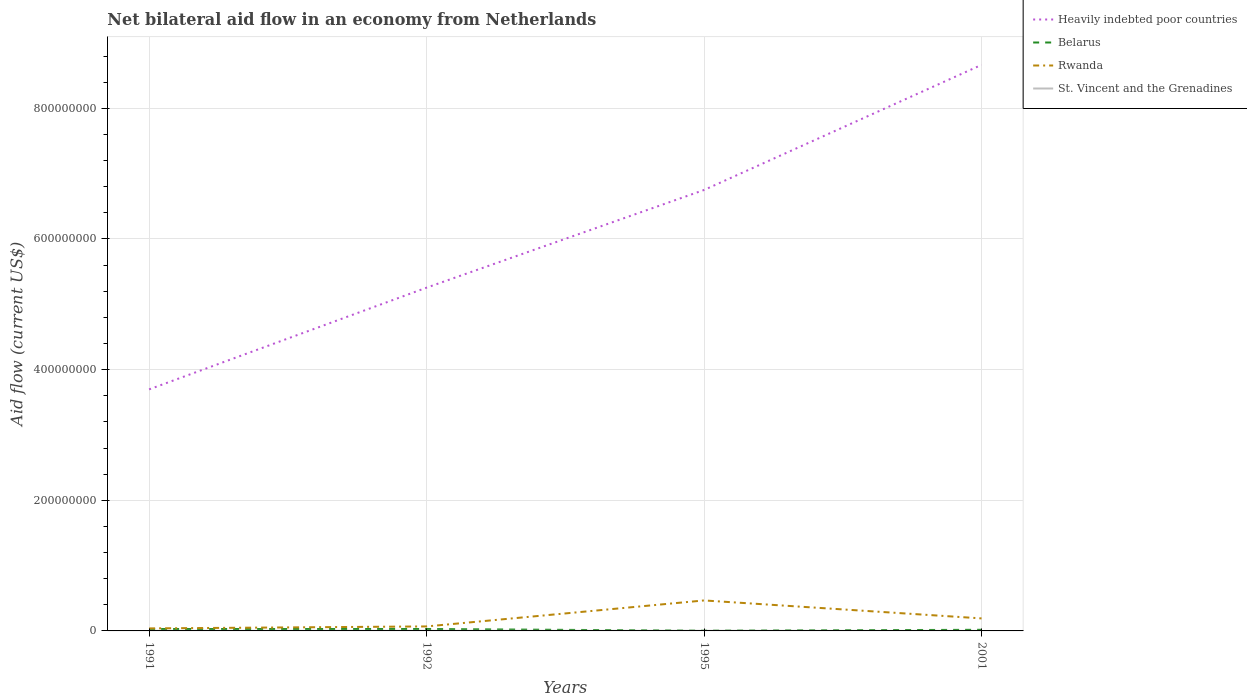How many different coloured lines are there?
Ensure brevity in your answer.  4. Does the line corresponding to Rwanda intersect with the line corresponding to Heavily indebted poor countries?
Give a very brief answer. No. Across all years, what is the maximum net bilateral aid flow in Heavily indebted poor countries?
Keep it short and to the point. 3.70e+08. In which year was the net bilateral aid flow in St. Vincent and the Grenadines maximum?
Give a very brief answer. 2001. What is the total net bilateral aid flow in Rwanda in the graph?
Your response must be concise. -1.23e+07. Is the net bilateral aid flow in Heavily indebted poor countries strictly greater than the net bilateral aid flow in St. Vincent and the Grenadines over the years?
Make the answer very short. No. What is the difference between two consecutive major ticks on the Y-axis?
Your answer should be compact. 2.00e+08. Does the graph contain grids?
Provide a succinct answer. Yes. Where does the legend appear in the graph?
Offer a terse response. Top right. What is the title of the graph?
Provide a short and direct response. Net bilateral aid flow in an economy from Netherlands. What is the label or title of the Y-axis?
Your response must be concise. Aid flow (current US$). What is the Aid flow (current US$) in Heavily indebted poor countries in 1991?
Keep it short and to the point. 3.70e+08. What is the Aid flow (current US$) of Belarus in 1991?
Keep it short and to the point. 2.90e+06. What is the Aid flow (current US$) in Rwanda in 1991?
Ensure brevity in your answer.  3.86e+06. What is the Aid flow (current US$) of St. Vincent and the Grenadines in 1991?
Make the answer very short. 1.10e+05. What is the Aid flow (current US$) of Heavily indebted poor countries in 1992?
Ensure brevity in your answer.  5.25e+08. What is the Aid flow (current US$) in Belarus in 1992?
Your response must be concise. 2.90e+06. What is the Aid flow (current US$) of Rwanda in 1992?
Your answer should be very brief. 6.88e+06. What is the Aid flow (current US$) of Heavily indebted poor countries in 1995?
Keep it short and to the point. 6.75e+08. What is the Aid flow (current US$) of Rwanda in 1995?
Your answer should be compact. 4.67e+07. What is the Aid flow (current US$) in St. Vincent and the Grenadines in 1995?
Provide a succinct answer. 1.60e+05. What is the Aid flow (current US$) in Heavily indebted poor countries in 2001?
Provide a succinct answer. 8.67e+08. What is the Aid flow (current US$) in Belarus in 2001?
Give a very brief answer. 1.72e+06. What is the Aid flow (current US$) of Rwanda in 2001?
Your answer should be compact. 1.92e+07. What is the Aid flow (current US$) in St. Vincent and the Grenadines in 2001?
Offer a very short reply. 5.00e+04. Across all years, what is the maximum Aid flow (current US$) in Heavily indebted poor countries?
Your answer should be very brief. 8.67e+08. Across all years, what is the maximum Aid flow (current US$) in Belarus?
Keep it short and to the point. 2.90e+06. Across all years, what is the maximum Aid flow (current US$) in Rwanda?
Your answer should be compact. 4.67e+07. Across all years, what is the maximum Aid flow (current US$) of St. Vincent and the Grenadines?
Offer a very short reply. 1.60e+05. Across all years, what is the minimum Aid flow (current US$) of Heavily indebted poor countries?
Give a very brief answer. 3.70e+08. Across all years, what is the minimum Aid flow (current US$) in Belarus?
Provide a short and direct response. 3.40e+05. Across all years, what is the minimum Aid flow (current US$) of Rwanda?
Your answer should be compact. 3.86e+06. What is the total Aid flow (current US$) in Heavily indebted poor countries in the graph?
Your answer should be compact. 2.44e+09. What is the total Aid flow (current US$) in Belarus in the graph?
Keep it short and to the point. 7.86e+06. What is the total Aid flow (current US$) of Rwanda in the graph?
Your answer should be compact. 7.66e+07. What is the total Aid flow (current US$) in St. Vincent and the Grenadines in the graph?
Provide a succinct answer. 4.80e+05. What is the difference between the Aid flow (current US$) in Heavily indebted poor countries in 1991 and that in 1992?
Offer a very short reply. -1.56e+08. What is the difference between the Aid flow (current US$) of Rwanda in 1991 and that in 1992?
Keep it short and to the point. -3.02e+06. What is the difference between the Aid flow (current US$) in St. Vincent and the Grenadines in 1991 and that in 1992?
Your answer should be very brief. -5.00e+04. What is the difference between the Aid flow (current US$) in Heavily indebted poor countries in 1991 and that in 1995?
Give a very brief answer. -3.05e+08. What is the difference between the Aid flow (current US$) of Belarus in 1991 and that in 1995?
Provide a short and direct response. 2.56e+06. What is the difference between the Aid flow (current US$) in Rwanda in 1991 and that in 1995?
Offer a terse response. -4.28e+07. What is the difference between the Aid flow (current US$) in St. Vincent and the Grenadines in 1991 and that in 1995?
Ensure brevity in your answer.  -5.00e+04. What is the difference between the Aid flow (current US$) of Heavily indebted poor countries in 1991 and that in 2001?
Your answer should be very brief. -4.97e+08. What is the difference between the Aid flow (current US$) in Belarus in 1991 and that in 2001?
Your response must be concise. 1.18e+06. What is the difference between the Aid flow (current US$) in Rwanda in 1991 and that in 2001?
Give a very brief answer. -1.53e+07. What is the difference between the Aid flow (current US$) of Heavily indebted poor countries in 1992 and that in 1995?
Make the answer very short. -1.50e+08. What is the difference between the Aid flow (current US$) in Belarus in 1992 and that in 1995?
Your response must be concise. 2.56e+06. What is the difference between the Aid flow (current US$) of Rwanda in 1992 and that in 1995?
Offer a very short reply. -3.98e+07. What is the difference between the Aid flow (current US$) of St. Vincent and the Grenadines in 1992 and that in 1995?
Make the answer very short. 0. What is the difference between the Aid flow (current US$) in Heavily indebted poor countries in 1992 and that in 2001?
Provide a succinct answer. -3.41e+08. What is the difference between the Aid flow (current US$) in Belarus in 1992 and that in 2001?
Ensure brevity in your answer.  1.18e+06. What is the difference between the Aid flow (current US$) in Rwanda in 1992 and that in 2001?
Your answer should be compact. -1.23e+07. What is the difference between the Aid flow (current US$) of Heavily indebted poor countries in 1995 and that in 2001?
Your answer should be compact. -1.92e+08. What is the difference between the Aid flow (current US$) in Belarus in 1995 and that in 2001?
Your answer should be compact. -1.38e+06. What is the difference between the Aid flow (current US$) in Rwanda in 1995 and that in 2001?
Offer a terse response. 2.75e+07. What is the difference between the Aid flow (current US$) of Heavily indebted poor countries in 1991 and the Aid flow (current US$) of Belarus in 1992?
Your answer should be very brief. 3.67e+08. What is the difference between the Aid flow (current US$) in Heavily indebted poor countries in 1991 and the Aid flow (current US$) in Rwanda in 1992?
Make the answer very short. 3.63e+08. What is the difference between the Aid flow (current US$) in Heavily indebted poor countries in 1991 and the Aid flow (current US$) in St. Vincent and the Grenadines in 1992?
Offer a terse response. 3.70e+08. What is the difference between the Aid flow (current US$) in Belarus in 1991 and the Aid flow (current US$) in Rwanda in 1992?
Give a very brief answer. -3.98e+06. What is the difference between the Aid flow (current US$) in Belarus in 1991 and the Aid flow (current US$) in St. Vincent and the Grenadines in 1992?
Offer a terse response. 2.74e+06. What is the difference between the Aid flow (current US$) in Rwanda in 1991 and the Aid flow (current US$) in St. Vincent and the Grenadines in 1992?
Give a very brief answer. 3.70e+06. What is the difference between the Aid flow (current US$) of Heavily indebted poor countries in 1991 and the Aid flow (current US$) of Belarus in 1995?
Your answer should be very brief. 3.69e+08. What is the difference between the Aid flow (current US$) in Heavily indebted poor countries in 1991 and the Aid flow (current US$) in Rwanda in 1995?
Your answer should be very brief. 3.23e+08. What is the difference between the Aid flow (current US$) of Heavily indebted poor countries in 1991 and the Aid flow (current US$) of St. Vincent and the Grenadines in 1995?
Your answer should be compact. 3.70e+08. What is the difference between the Aid flow (current US$) in Belarus in 1991 and the Aid flow (current US$) in Rwanda in 1995?
Your answer should be very brief. -4.38e+07. What is the difference between the Aid flow (current US$) of Belarus in 1991 and the Aid flow (current US$) of St. Vincent and the Grenadines in 1995?
Give a very brief answer. 2.74e+06. What is the difference between the Aid flow (current US$) of Rwanda in 1991 and the Aid flow (current US$) of St. Vincent and the Grenadines in 1995?
Your response must be concise. 3.70e+06. What is the difference between the Aid flow (current US$) in Heavily indebted poor countries in 1991 and the Aid flow (current US$) in Belarus in 2001?
Your answer should be very brief. 3.68e+08. What is the difference between the Aid flow (current US$) in Heavily indebted poor countries in 1991 and the Aid flow (current US$) in Rwanda in 2001?
Offer a terse response. 3.51e+08. What is the difference between the Aid flow (current US$) in Heavily indebted poor countries in 1991 and the Aid flow (current US$) in St. Vincent and the Grenadines in 2001?
Provide a succinct answer. 3.70e+08. What is the difference between the Aid flow (current US$) in Belarus in 1991 and the Aid flow (current US$) in Rwanda in 2001?
Your response must be concise. -1.63e+07. What is the difference between the Aid flow (current US$) in Belarus in 1991 and the Aid flow (current US$) in St. Vincent and the Grenadines in 2001?
Offer a terse response. 2.85e+06. What is the difference between the Aid flow (current US$) in Rwanda in 1991 and the Aid flow (current US$) in St. Vincent and the Grenadines in 2001?
Ensure brevity in your answer.  3.81e+06. What is the difference between the Aid flow (current US$) of Heavily indebted poor countries in 1992 and the Aid flow (current US$) of Belarus in 1995?
Provide a succinct answer. 5.25e+08. What is the difference between the Aid flow (current US$) of Heavily indebted poor countries in 1992 and the Aid flow (current US$) of Rwanda in 1995?
Offer a terse response. 4.79e+08. What is the difference between the Aid flow (current US$) in Heavily indebted poor countries in 1992 and the Aid flow (current US$) in St. Vincent and the Grenadines in 1995?
Offer a terse response. 5.25e+08. What is the difference between the Aid flow (current US$) in Belarus in 1992 and the Aid flow (current US$) in Rwanda in 1995?
Offer a terse response. -4.38e+07. What is the difference between the Aid flow (current US$) in Belarus in 1992 and the Aid flow (current US$) in St. Vincent and the Grenadines in 1995?
Provide a succinct answer. 2.74e+06. What is the difference between the Aid flow (current US$) in Rwanda in 1992 and the Aid flow (current US$) in St. Vincent and the Grenadines in 1995?
Your answer should be compact. 6.72e+06. What is the difference between the Aid flow (current US$) in Heavily indebted poor countries in 1992 and the Aid flow (current US$) in Belarus in 2001?
Your answer should be very brief. 5.24e+08. What is the difference between the Aid flow (current US$) in Heavily indebted poor countries in 1992 and the Aid flow (current US$) in Rwanda in 2001?
Make the answer very short. 5.06e+08. What is the difference between the Aid flow (current US$) of Heavily indebted poor countries in 1992 and the Aid flow (current US$) of St. Vincent and the Grenadines in 2001?
Your answer should be compact. 5.25e+08. What is the difference between the Aid flow (current US$) in Belarus in 1992 and the Aid flow (current US$) in Rwanda in 2001?
Offer a very short reply. -1.63e+07. What is the difference between the Aid flow (current US$) of Belarus in 1992 and the Aid flow (current US$) of St. Vincent and the Grenadines in 2001?
Give a very brief answer. 2.85e+06. What is the difference between the Aid flow (current US$) in Rwanda in 1992 and the Aid flow (current US$) in St. Vincent and the Grenadines in 2001?
Your response must be concise. 6.83e+06. What is the difference between the Aid flow (current US$) in Heavily indebted poor countries in 1995 and the Aid flow (current US$) in Belarus in 2001?
Make the answer very short. 6.73e+08. What is the difference between the Aid flow (current US$) in Heavily indebted poor countries in 1995 and the Aid flow (current US$) in Rwanda in 2001?
Ensure brevity in your answer.  6.56e+08. What is the difference between the Aid flow (current US$) of Heavily indebted poor countries in 1995 and the Aid flow (current US$) of St. Vincent and the Grenadines in 2001?
Offer a very short reply. 6.75e+08. What is the difference between the Aid flow (current US$) in Belarus in 1995 and the Aid flow (current US$) in Rwanda in 2001?
Ensure brevity in your answer.  -1.88e+07. What is the difference between the Aid flow (current US$) of Belarus in 1995 and the Aid flow (current US$) of St. Vincent and the Grenadines in 2001?
Ensure brevity in your answer.  2.90e+05. What is the difference between the Aid flow (current US$) of Rwanda in 1995 and the Aid flow (current US$) of St. Vincent and the Grenadines in 2001?
Make the answer very short. 4.66e+07. What is the average Aid flow (current US$) in Heavily indebted poor countries per year?
Ensure brevity in your answer.  6.09e+08. What is the average Aid flow (current US$) in Belarus per year?
Provide a short and direct response. 1.96e+06. What is the average Aid flow (current US$) in Rwanda per year?
Your answer should be compact. 1.91e+07. What is the average Aid flow (current US$) of St. Vincent and the Grenadines per year?
Offer a very short reply. 1.20e+05. In the year 1991, what is the difference between the Aid flow (current US$) of Heavily indebted poor countries and Aid flow (current US$) of Belarus?
Give a very brief answer. 3.67e+08. In the year 1991, what is the difference between the Aid flow (current US$) of Heavily indebted poor countries and Aid flow (current US$) of Rwanda?
Make the answer very short. 3.66e+08. In the year 1991, what is the difference between the Aid flow (current US$) of Heavily indebted poor countries and Aid flow (current US$) of St. Vincent and the Grenadines?
Your answer should be compact. 3.70e+08. In the year 1991, what is the difference between the Aid flow (current US$) of Belarus and Aid flow (current US$) of Rwanda?
Make the answer very short. -9.60e+05. In the year 1991, what is the difference between the Aid flow (current US$) in Belarus and Aid flow (current US$) in St. Vincent and the Grenadines?
Give a very brief answer. 2.79e+06. In the year 1991, what is the difference between the Aid flow (current US$) of Rwanda and Aid flow (current US$) of St. Vincent and the Grenadines?
Ensure brevity in your answer.  3.75e+06. In the year 1992, what is the difference between the Aid flow (current US$) in Heavily indebted poor countries and Aid flow (current US$) in Belarus?
Give a very brief answer. 5.23e+08. In the year 1992, what is the difference between the Aid flow (current US$) of Heavily indebted poor countries and Aid flow (current US$) of Rwanda?
Ensure brevity in your answer.  5.19e+08. In the year 1992, what is the difference between the Aid flow (current US$) in Heavily indebted poor countries and Aid flow (current US$) in St. Vincent and the Grenadines?
Give a very brief answer. 5.25e+08. In the year 1992, what is the difference between the Aid flow (current US$) in Belarus and Aid flow (current US$) in Rwanda?
Your answer should be compact. -3.98e+06. In the year 1992, what is the difference between the Aid flow (current US$) in Belarus and Aid flow (current US$) in St. Vincent and the Grenadines?
Your answer should be compact. 2.74e+06. In the year 1992, what is the difference between the Aid flow (current US$) of Rwanda and Aid flow (current US$) of St. Vincent and the Grenadines?
Offer a terse response. 6.72e+06. In the year 1995, what is the difference between the Aid flow (current US$) of Heavily indebted poor countries and Aid flow (current US$) of Belarus?
Provide a short and direct response. 6.75e+08. In the year 1995, what is the difference between the Aid flow (current US$) in Heavily indebted poor countries and Aid flow (current US$) in Rwanda?
Provide a succinct answer. 6.28e+08. In the year 1995, what is the difference between the Aid flow (current US$) of Heavily indebted poor countries and Aid flow (current US$) of St. Vincent and the Grenadines?
Provide a short and direct response. 6.75e+08. In the year 1995, what is the difference between the Aid flow (current US$) in Belarus and Aid flow (current US$) in Rwanda?
Your response must be concise. -4.63e+07. In the year 1995, what is the difference between the Aid flow (current US$) in Rwanda and Aid flow (current US$) in St. Vincent and the Grenadines?
Your answer should be compact. 4.65e+07. In the year 2001, what is the difference between the Aid flow (current US$) in Heavily indebted poor countries and Aid flow (current US$) in Belarus?
Your answer should be compact. 8.65e+08. In the year 2001, what is the difference between the Aid flow (current US$) in Heavily indebted poor countries and Aid flow (current US$) in Rwanda?
Ensure brevity in your answer.  8.47e+08. In the year 2001, what is the difference between the Aid flow (current US$) of Heavily indebted poor countries and Aid flow (current US$) of St. Vincent and the Grenadines?
Give a very brief answer. 8.66e+08. In the year 2001, what is the difference between the Aid flow (current US$) in Belarus and Aid flow (current US$) in Rwanda?
Offer a very short reply. -1.74e+07. In the year 2001, what is the difference between the Aid flow (current US$) in Belarus and Aid flow (current US$) in St. Vincent and the Grenadines?
Your response must be concise. 1.67e+06. In the year 2001, what is the difference between the Aid flow (current US$) in Rwanda and Aid flow (current US$) in St. Vincent and the Grenadines?
Give a very brief answer. 1.91e+07. What is the ratio of the Aid flow (current US$) of Heavily indebted poor countries in 1991 to that in 1992?
Provide a succinct answer. 0.7. What is the ratio of the Aid flow (current US$) of Belarus in 1991 to that in 1992?
Your answer should be compact. 1. What is the ratio of the Aid flow (current US$) in Rwanda in 1991 to that in 1992?
Make the answer very short. 0.56. What is the ratio of the Aid flow (current US$) in St. Vincent and the Grenadines in 1991 to that in 1992?
Provide a succinct answer. 0.69. What is the ratio of the Aid flow (current US$) of Heavily indebted poor countries in 1991 to that in 1995?
Ensure brevity in your answer.  0.55. What is the ratio of the Aid flow (current US$) in Belarus in 1991 to that in 1995?
Ensure brevity in your answer.  8.53. What is the ratio of the Aid flow (current US$) of Rwanda in 1991 to that in 1995?
Make the answer very short. 0.08. What is the ratio of the Aid flow (current US$) of St. Vincent and the Grenadines in 1991 to that in 1995?
Keep it short and to the point. 0.69. What is the ratio of the Aid flow (current US$) in Heavily indebted poor countries in 1991 to that in 2001?
Offer a terse response. 0.43. What is the ratio of the Aid flow (current US$) in Belarus in 1991 to that in 2001?
Give a very brief answer. 1.69. What is the ratio of the Aid flow (current US$) of Rwanda in 1991 to that in 2001?
Ensure brevity in your answer.  0.2. What is the ratio of the Aid flow (current US$) in Heavily indebted poor countries in 1992 to that in 1995?
Your response must be concise. 0.78. What is the ratio of the Aid flow (current US$) of Belarus in 1992 to that in 1995?
Your answer should be compact. 8.53. What is the ratio of the Aid flow (current US$) in Rwanda in 1992 to that in 1995?
Provide a short and direct response. 0.15. What is the ratio of the Aid flow (current US$) in St. Vincent and the Grenadines in 1992 to that in 1995?
Make the answer very short. 1. What is the ratio of the Aid flow (current US$) in Heavily indebted poor countries in 1992 to that in 2001?
Provide a succinct answer. 0.61. What is the ratio of the Aid flow (current US$) of Belarus in 1992 to that in 2001?
Keep it short and to the point. 1.69. What is the ratio of the Aid flow (current US$) in Rwanda in 1992 to that in 2001?
Give a very brief answer. 0.36. What is the ratio of the Aid flow (current US$) of St. Vincent and the Grenadines in 1992 to that in 2001?
Make the answer very short. 3.2. What is the ratio of the Aid flow (current US$) in Heavily indebted poor countries in 1995 to that in 2001?
Your response must be concise. 0.78. What is the ratio of the Aid flow (current US$) of Belarus in 1995 to that in 2001?
Make the answer very short. 0.2. What is the ratio of the Aid flow (current US$) in Rwanda in 1995 to that in 2001?
Offer a terse response. 2.44. What is the difference between the highest and the second highest Aid flow (current US$) of Heavily indebted poor countries?
Give a very brief answer. 1.92e+08. What is the difference between the highest and the second highest Aid flow (current US$) in Belarus?
Offer a very short reply. 0. What is the difference between the highest and the second highest Aid flow (current US$) in Rwanda?
Provide a succinct answer. 2.75e+07. What is the difference between the highest and the lowest Aid flow (current US$) in Heavily indebted poor countries?
Provide a succinct answer. 4.97e+08. What is the difference between the highest and the lowest Aid flow (current US$) of Belarus?
Keep it short and to the point. 2.56e+06. What is the difference between the highest and the lowest Aid flow (current US$) in Rwanda?
Keep it short and to the point. 4.28e+07. What is the difference between the highest and the lowest Aid flow (current US$) of St. Vincent and the Grenadines?
Offer a very short reply. 1.10e+05. 